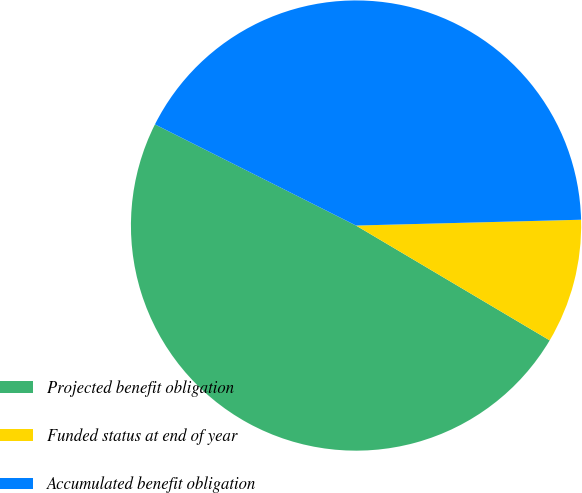Convert chart to OTSL. <chart><loc_0><loc_0><loc_500><loc_500><pie_chart><fcel>Projected benefit obligation<fcel>Funded status at end of year<fcel>Accumulated benefit obligation<nl><fcel>48.9%<fcel>8.93%<fcel>42.17%<nl></chart> 